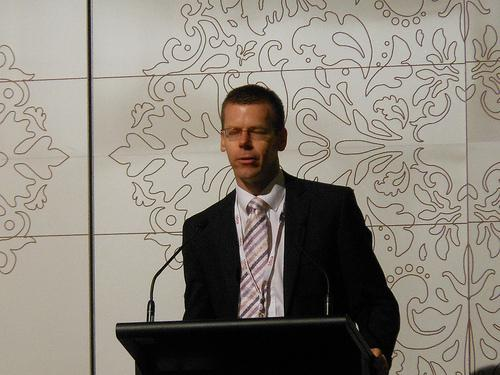Mention the attire and accessories of the person in the image and what they are engaged in. The man, in a white buttoned-down shirt, black suit jacket, and striped tie, wears eyeglasses and a lanyard while addressing a microphone at a black podium stand. Write a short description of the man's appearance and his current activity in the image. A man with short, medium brown hair and glasses is seen speaking into a microphone at a black podium; he is wearing a white shirt, striped tie, and black suit jacket. Explain what the person is doing and what they are wearing in the image. A man is speaking into a small microphone at a podium, dressed in a dark suit jacket, white button-down shirt, striped tie, and glasses, with his eyes closed. Explain what the man in the image is doing and list the main components of his outfit. The man is speaking into a microphone at a podium, wearing a dark-colored suit jacket, a white dress shirt, a light-colored striped tie, and eyeglasses. Provide a concise summary of the scene, highlighting the person's attire and activity. A man in a black suit, white shirt, and striped tie, sporting glasses and a lanyard, is delivering a speech at a podium into a microphone with his eyes closed. Mention the most prominent features of the individual in the image. The man has short brown hair, wears clear glasses, a light striped tie, a white dress shirt, a black suit jacket, and has his eyes closed. Describe the most noticeable elements of the image, focusing especially on the person's face. A man with closed eyelids, eyeglasses, and short brown hair speaks into a microphone while wearing a striped tie, white collar dress shirt, and black suit jacket. Describe the man's action and appearance, focusing on his clothes and facial features. A man with short dark hair, closed eyes, and glasses is addressing a group from a black podium, dressed in a smart suit, white dress shirt, and a striped tie. Briefly narrate the scene depicted in the image. A man with short hair, glasses, and a striped tie appears to be speaking into a microphone at a black podium while wearing a dark suit and white shirt. Using descriptive words, provide a summary of the person and their attire in the image. A bespectacled man with closed eyes, short brown hair, and a striped necktie is addressing an audience at a podium, clad in a smart black suit and crisp white shirt. 